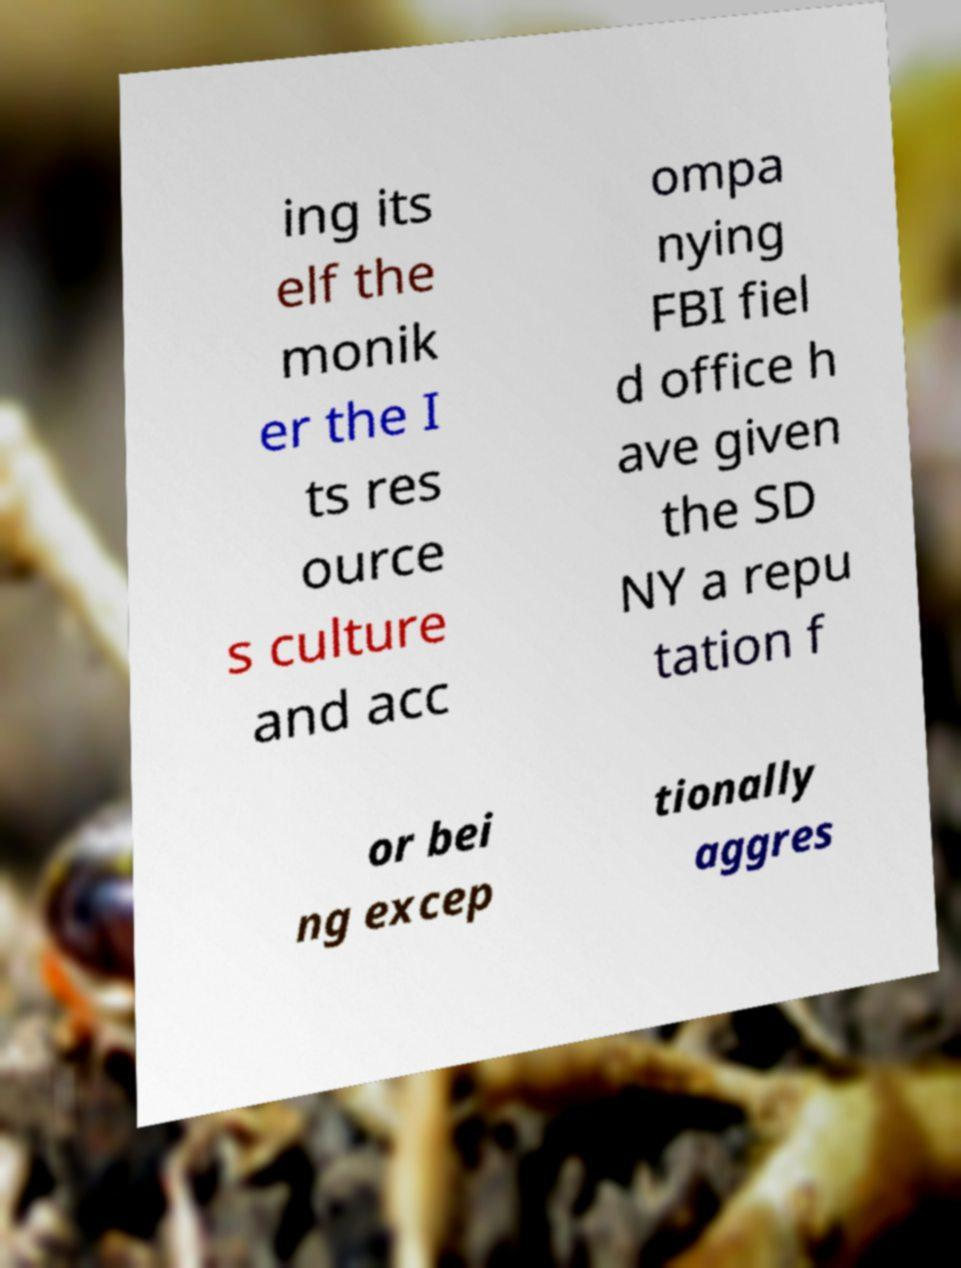Could you assist in decoding the text presented in this image and type it out clearly? ing its elf the monik er the I ts res ource s culture and acc ompa nying FBI fiel d office h ave given the SD NY a repu tation f or bei ng excep tionally aggres 